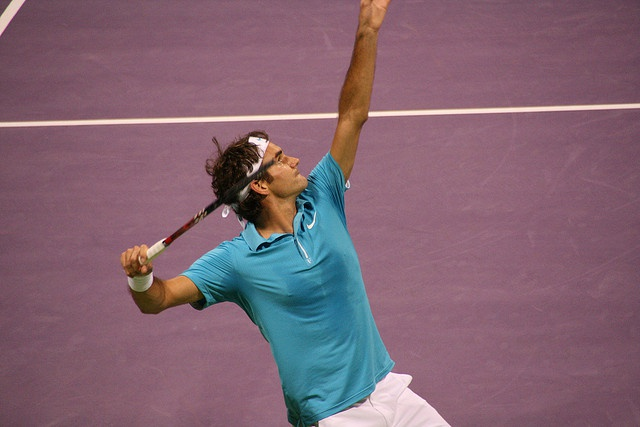Describe the objects in this image and their specific colors. I can see people in purple, teal, and black tones and tennis racket in purple, black, gray, maroon, and tan tones in this image. 